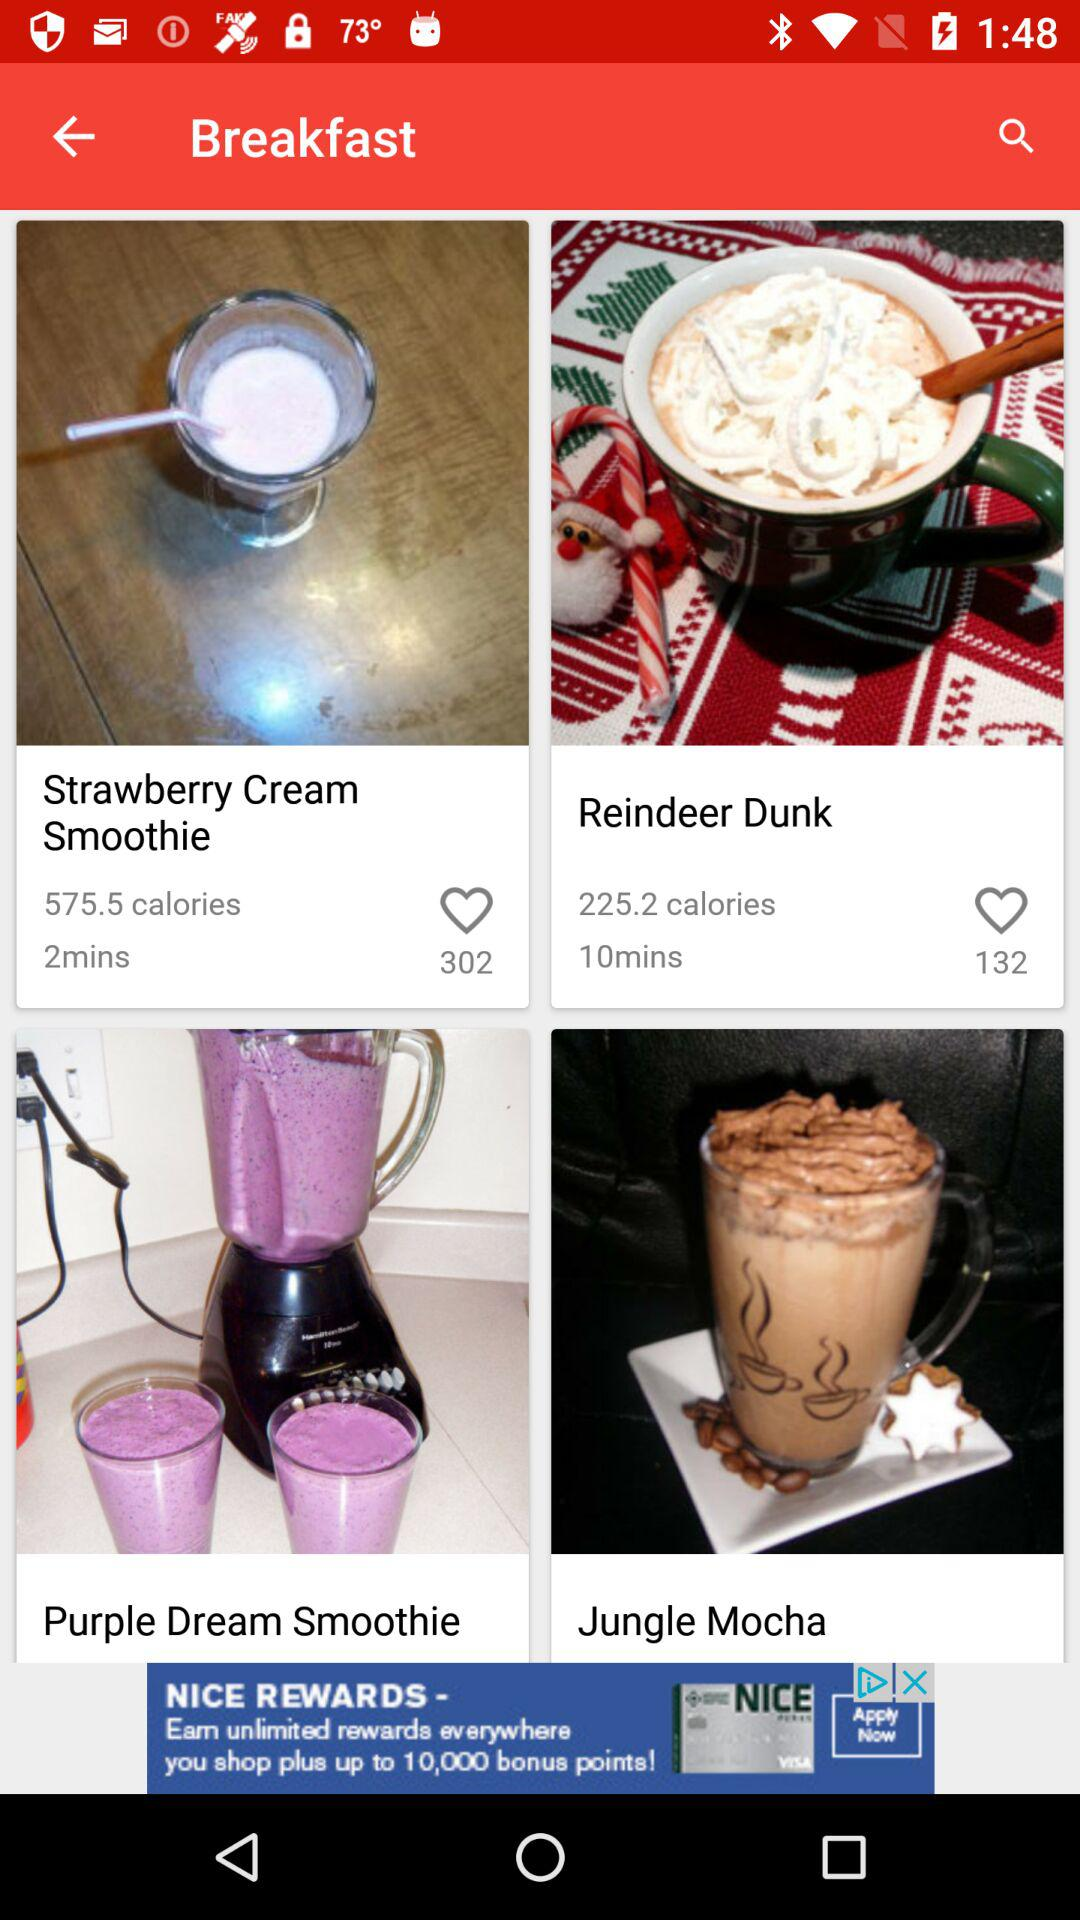What is the calorie count of a "Reindeer Dunk"? The calorie count of a "Reindeer Dunk" is 225.2. 